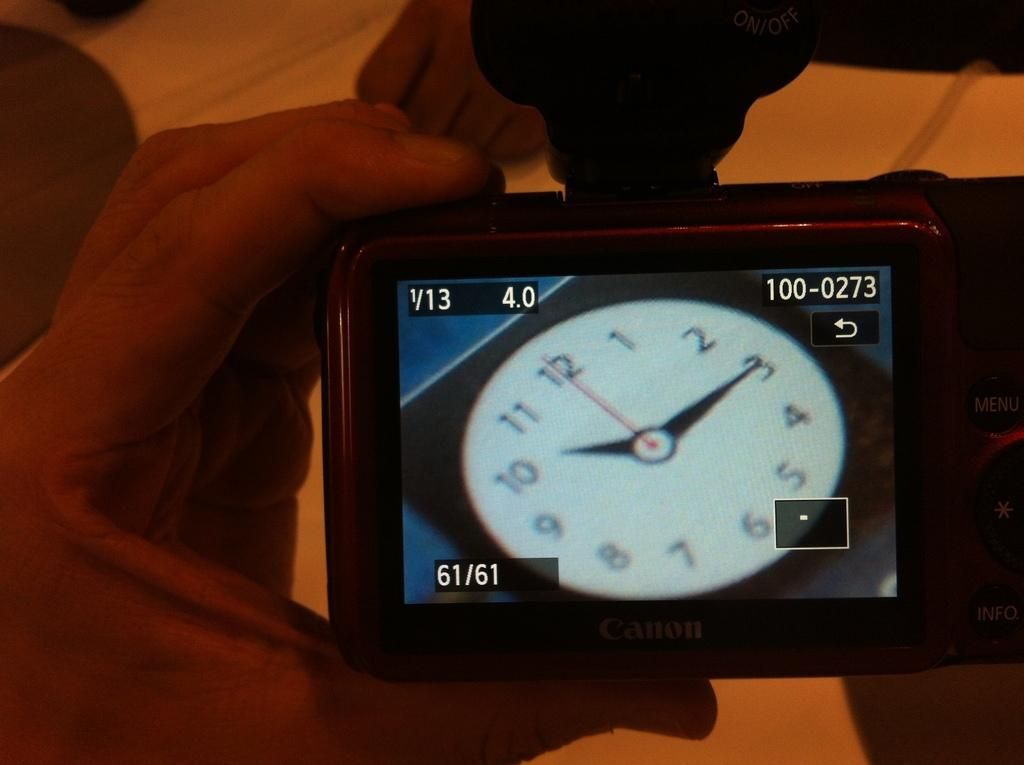Provide a one-sentence caption for the provided image. A clock is showing that the time is 10:15. 